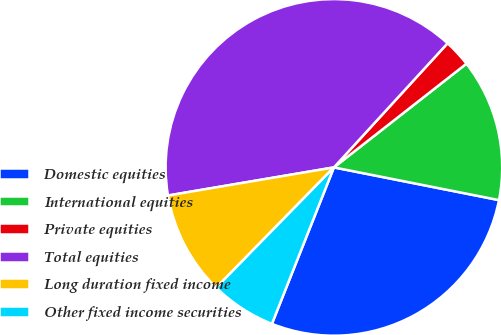<chart> <loc_0><loc_0><loc_500><loc_500><pie_chart><fcel>Domestic equities<fcel>International equities<fcel>Private equities<fcel>Total equities<fcel>Long duration fixed income<fcel>Other fixed income securities<nl><fcel>27.89%<fcel>13.68%<fcel>2.63%<fcel>39.47%<fcel>10.0%<fcel>6.32%<nl></chart> 